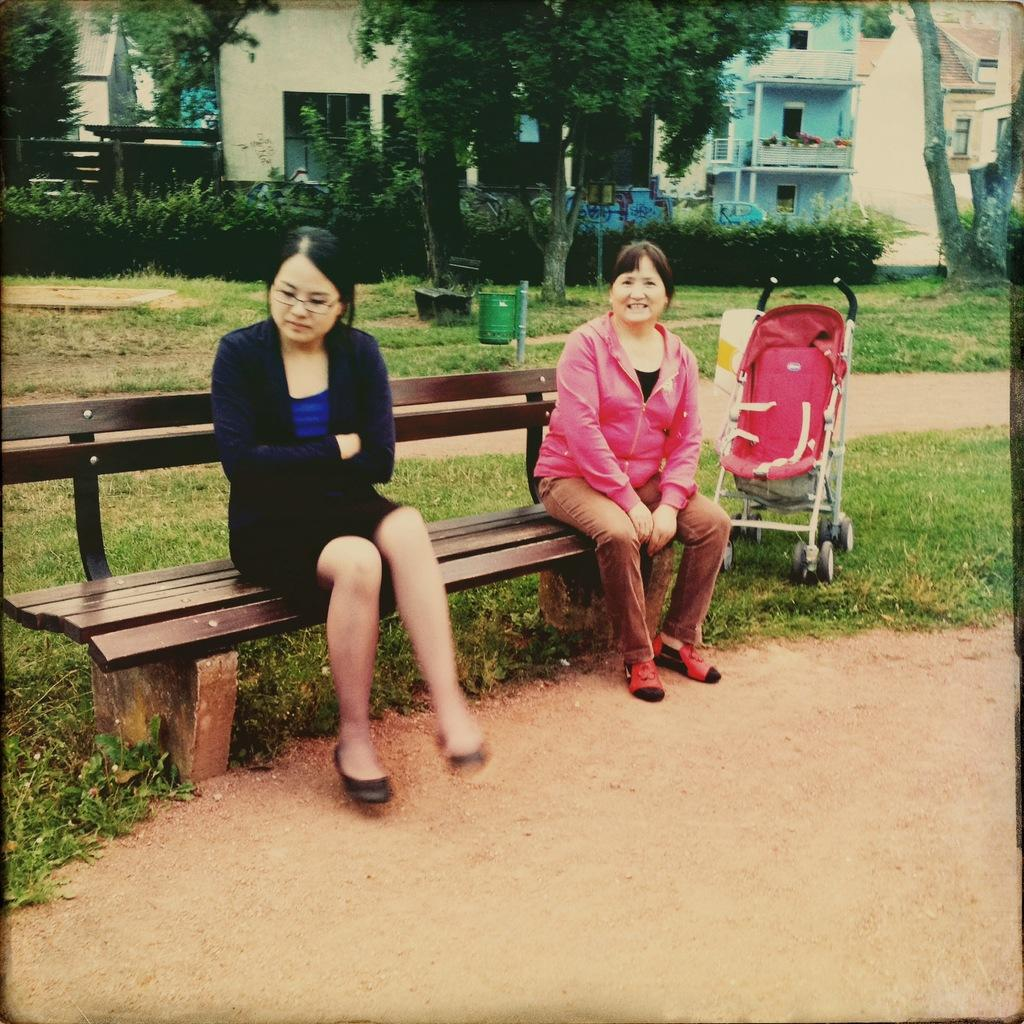What are the two ladies doing in the image? The two ladies are sitting on a desk in the image. What is located near the ladies? There is a baby trolley nearby. What type of natural elements can be seen in the image? Trees and plants are visible in the image. Can you describe any other objects in the image? There are other unspecified objects in the image, but their details are not provided. What type of bridge can be seen in the image? There is no bridge present in the image. Who is the actor in the image? The provided facts do not mention any actors in the image. 